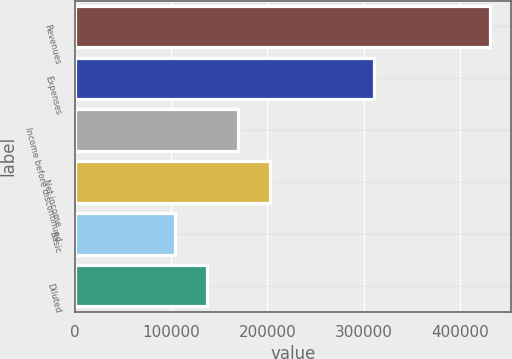Convert chart. <chart><loc_0><loc_0><loc_500><loc_500><bar_chart><fcel>Revenues<fcel>Expenses<fcel>Income before discontinued<fcel>Net income<fcel>Basic<fcel>Diluted<nl><fcel>431998<fcel>311227<fcel>169489<fcel>202303<fcel>103862<fcel>136676<nl></chart> 